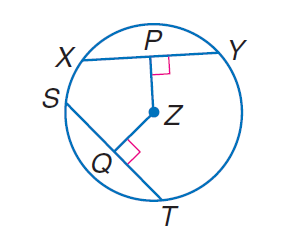Question: In \odot Z, P Z = Z Q, X Y = 4 a - 5, and S T = - 5 a + 13. Find S Q.
Choices:
A. 1.5
B. 2
C. 3
D. 4
Answer with the letter. Answer: A 